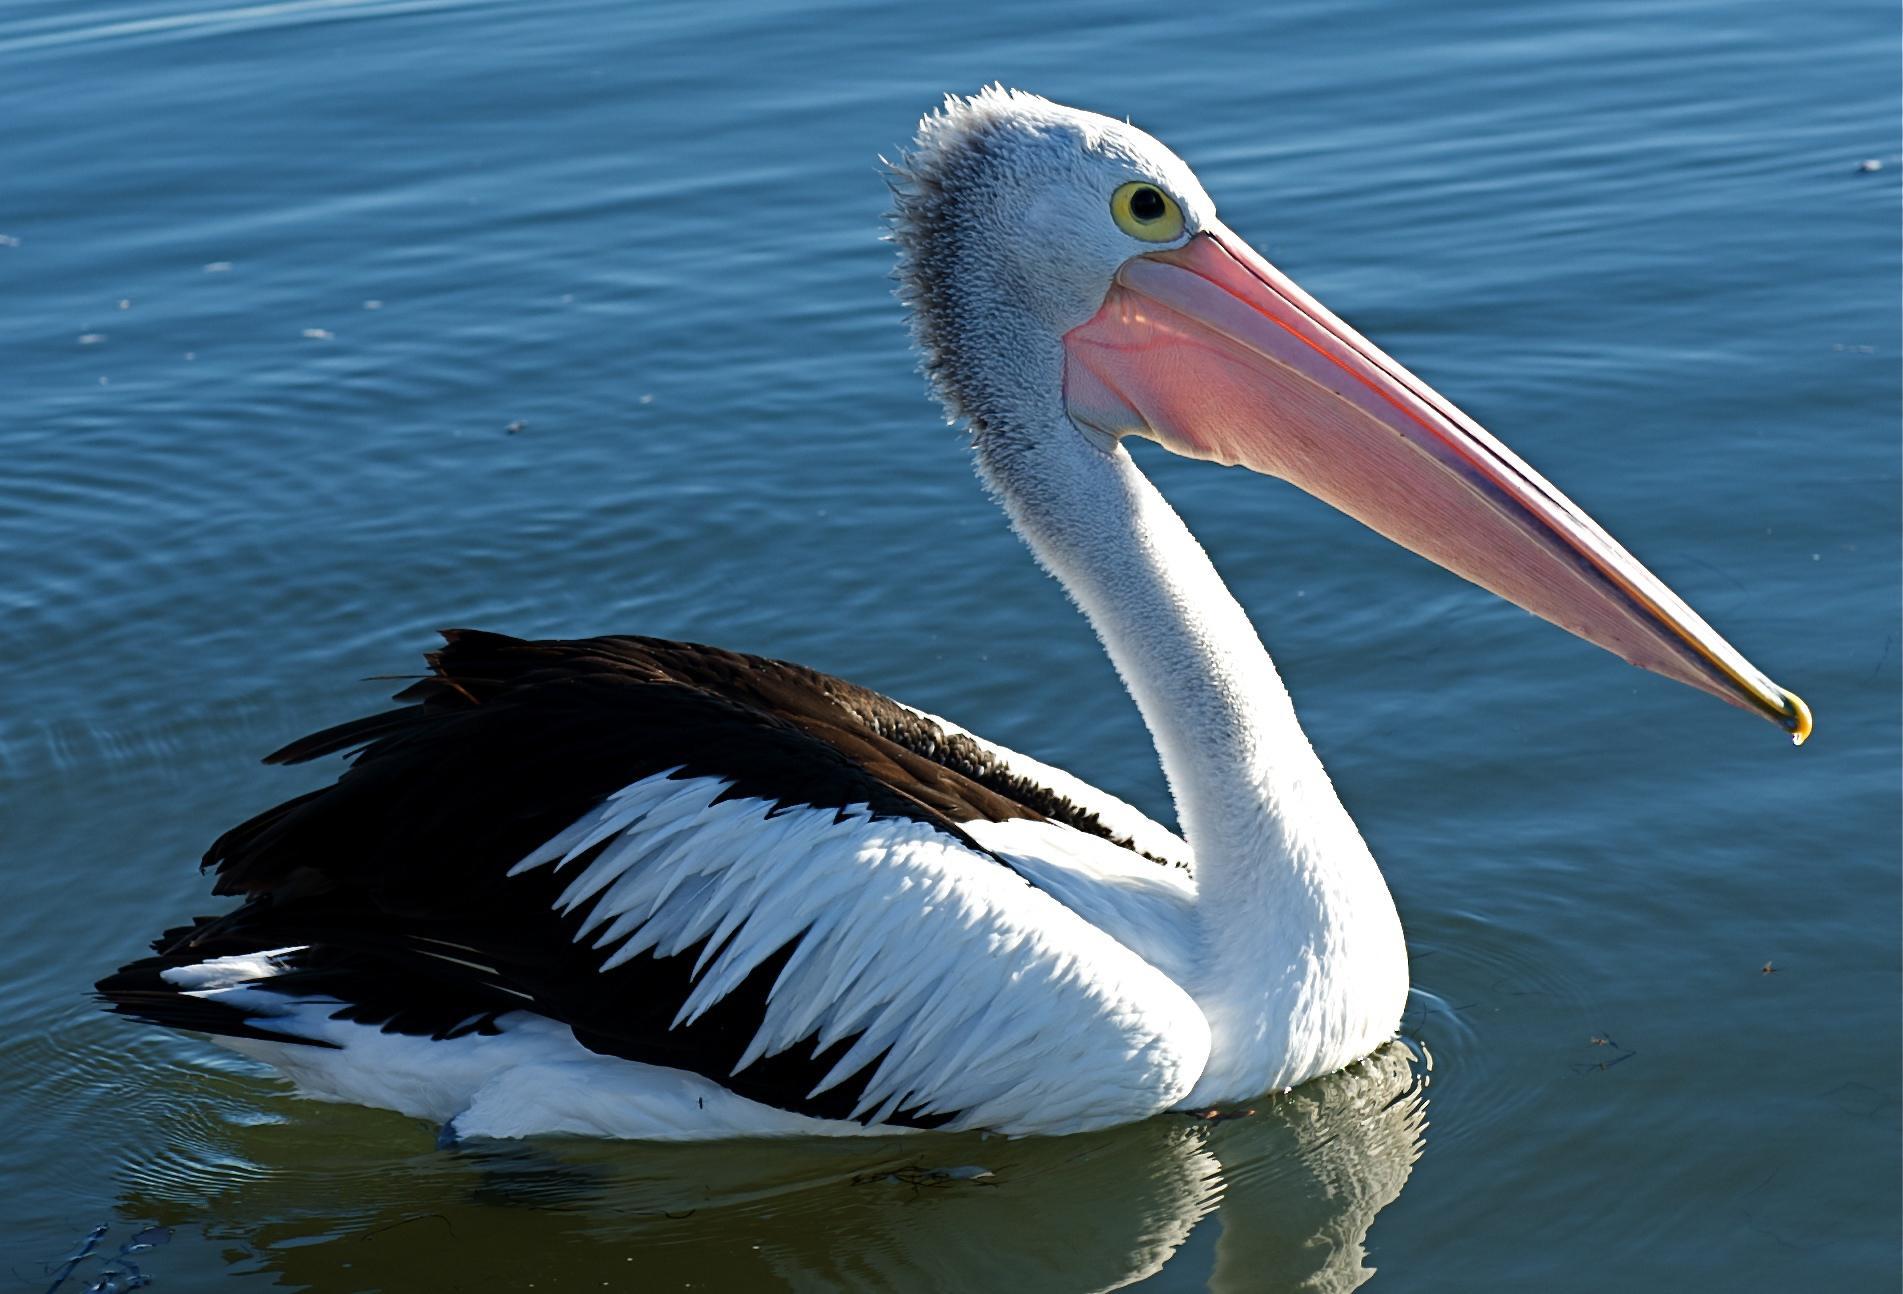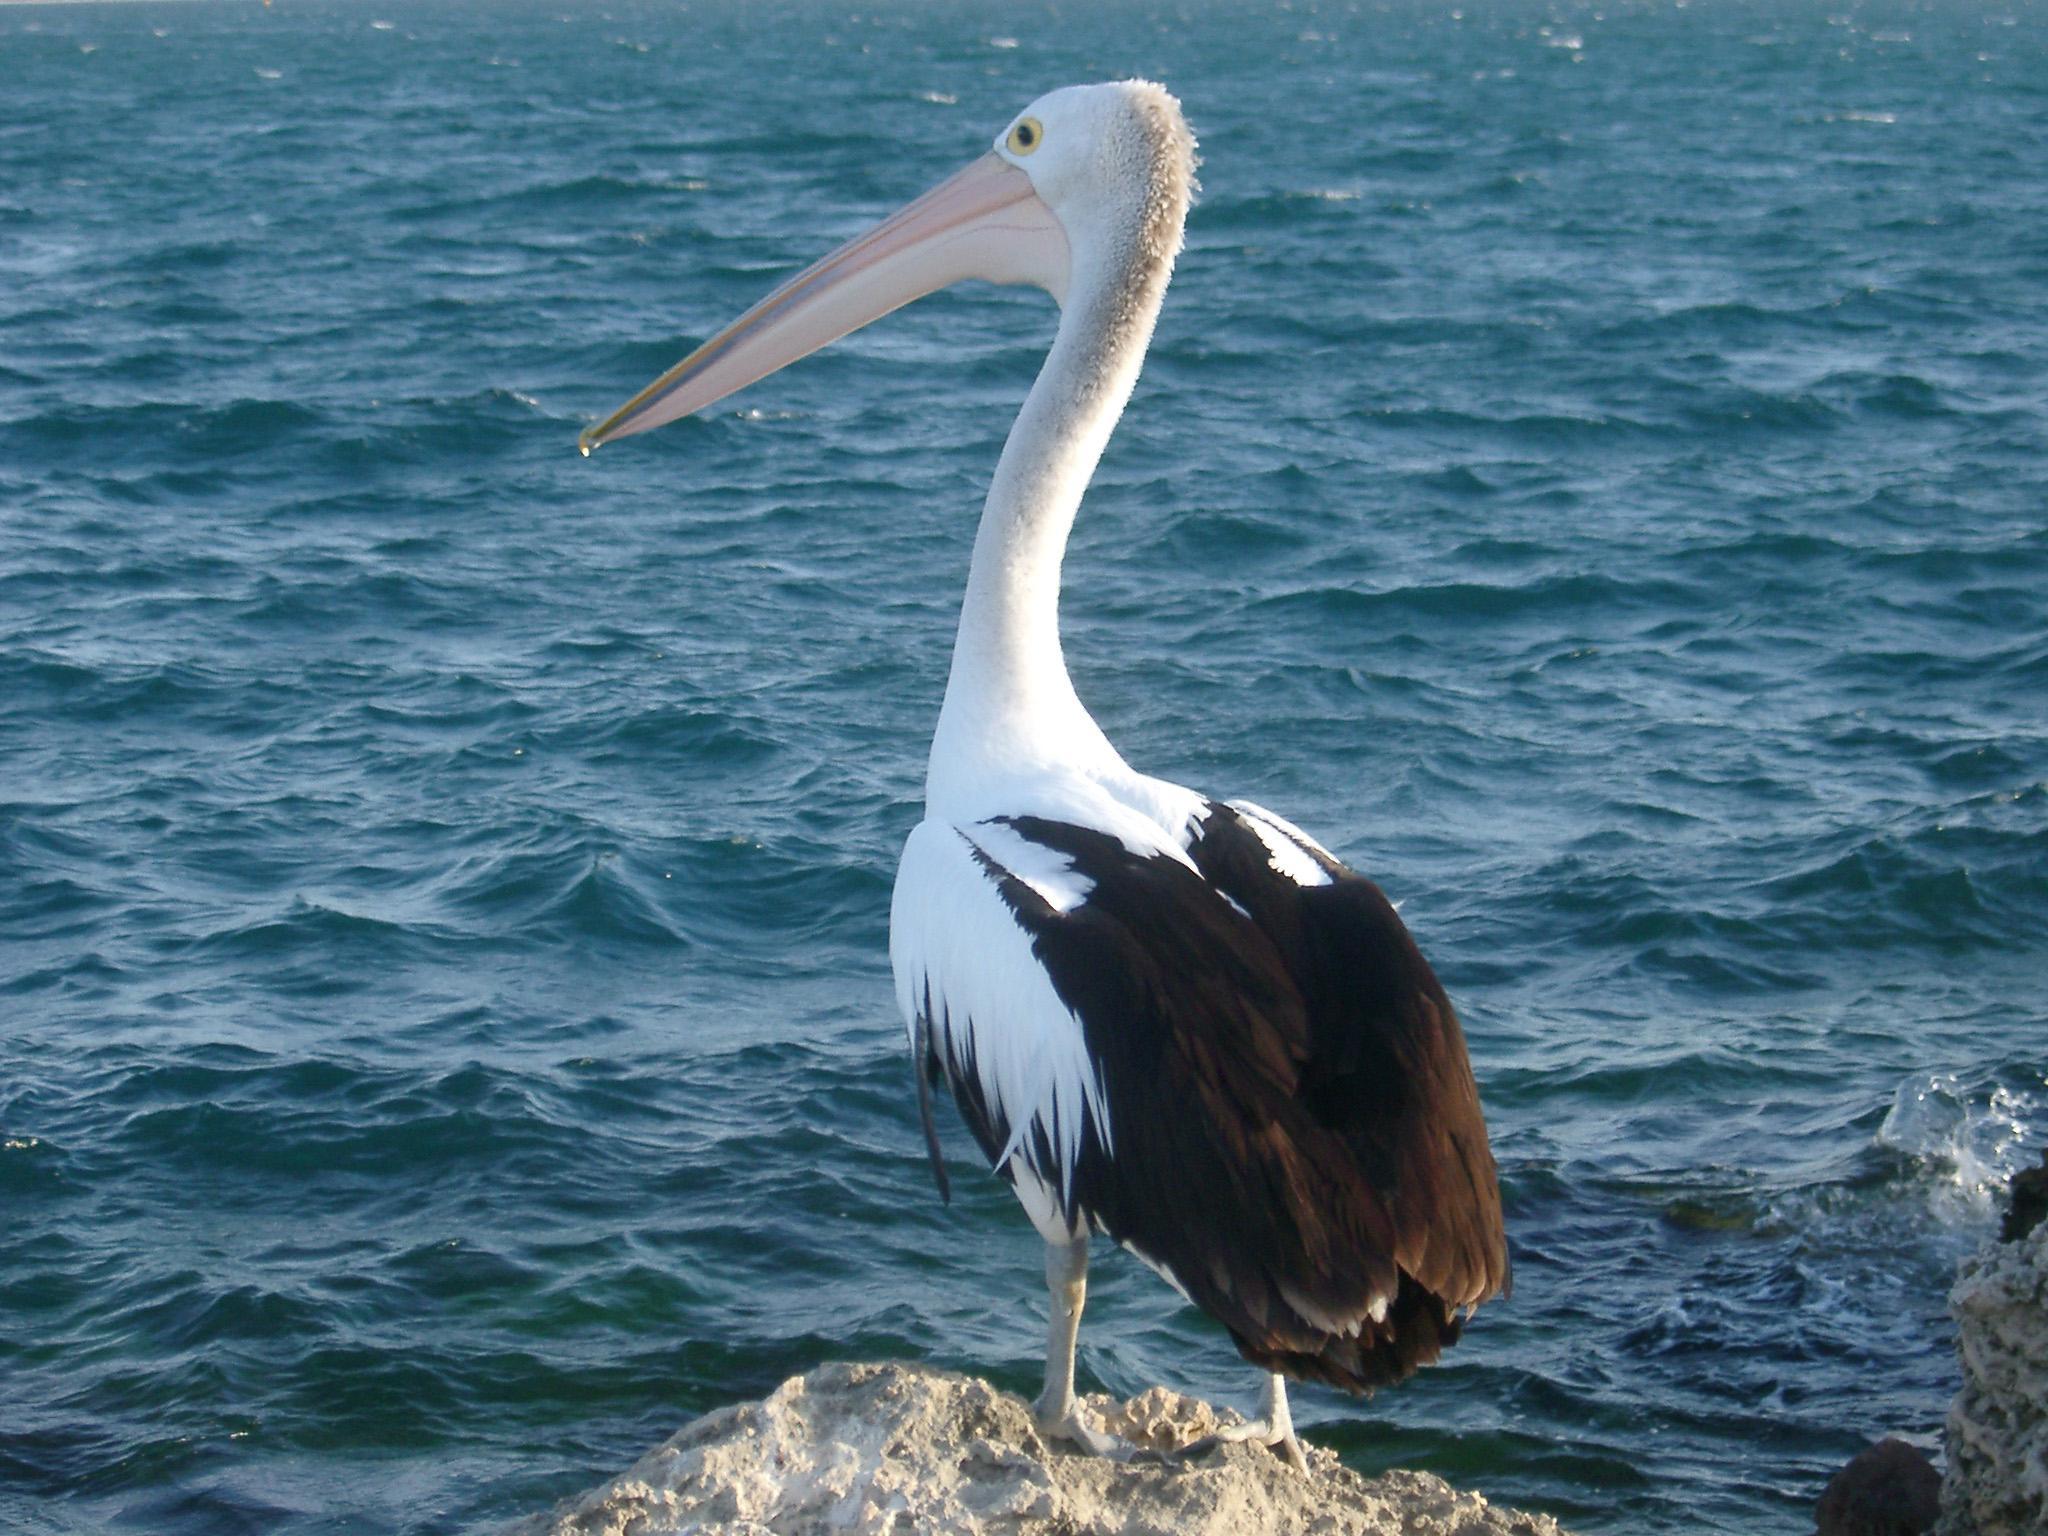The first image is the image on the left, the second image is the image on the right. For the images displayed, is the sentence "There are exactly two birds in one of the images." factually correct? Answer yes or no. No. 